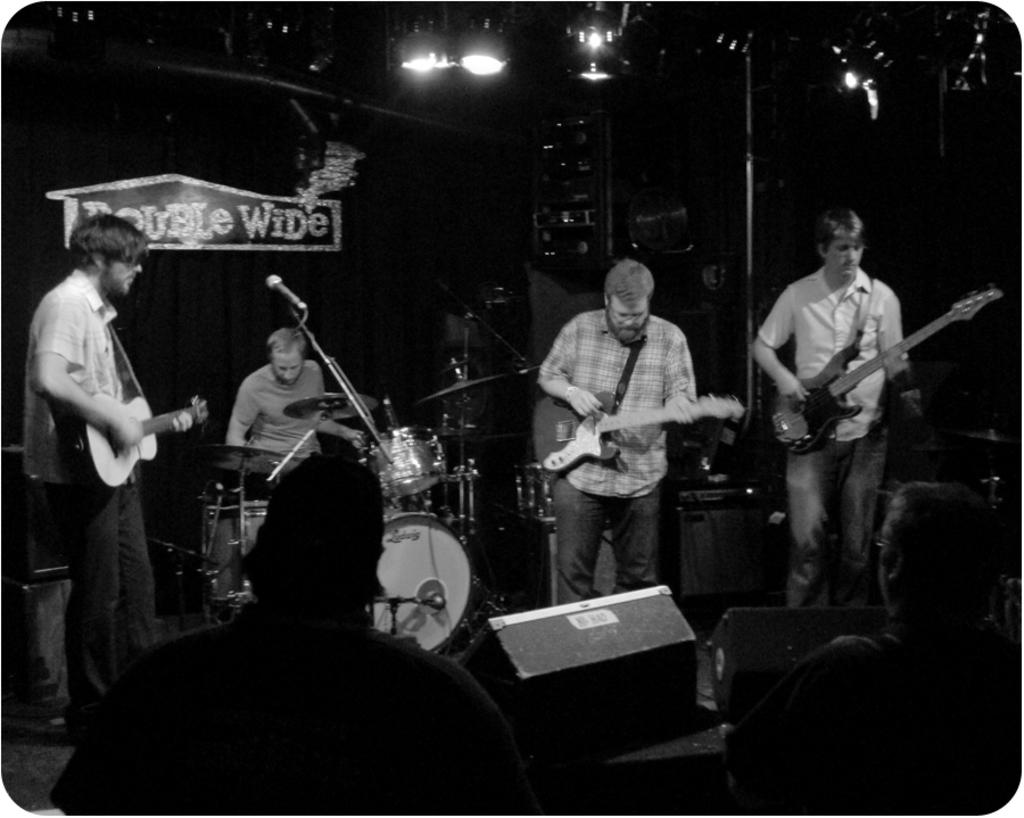How many people are in the image? There are four men in the image. What are the men doing in the image? The men are playing musical instruments. What can be seen in the background of the image? There is a board in the background of the image. What is the source of light in the image? There is a light at the top of the image. Can you see an umbrella being used by one of the men in the image? No, there is no umbrella present in the image. 